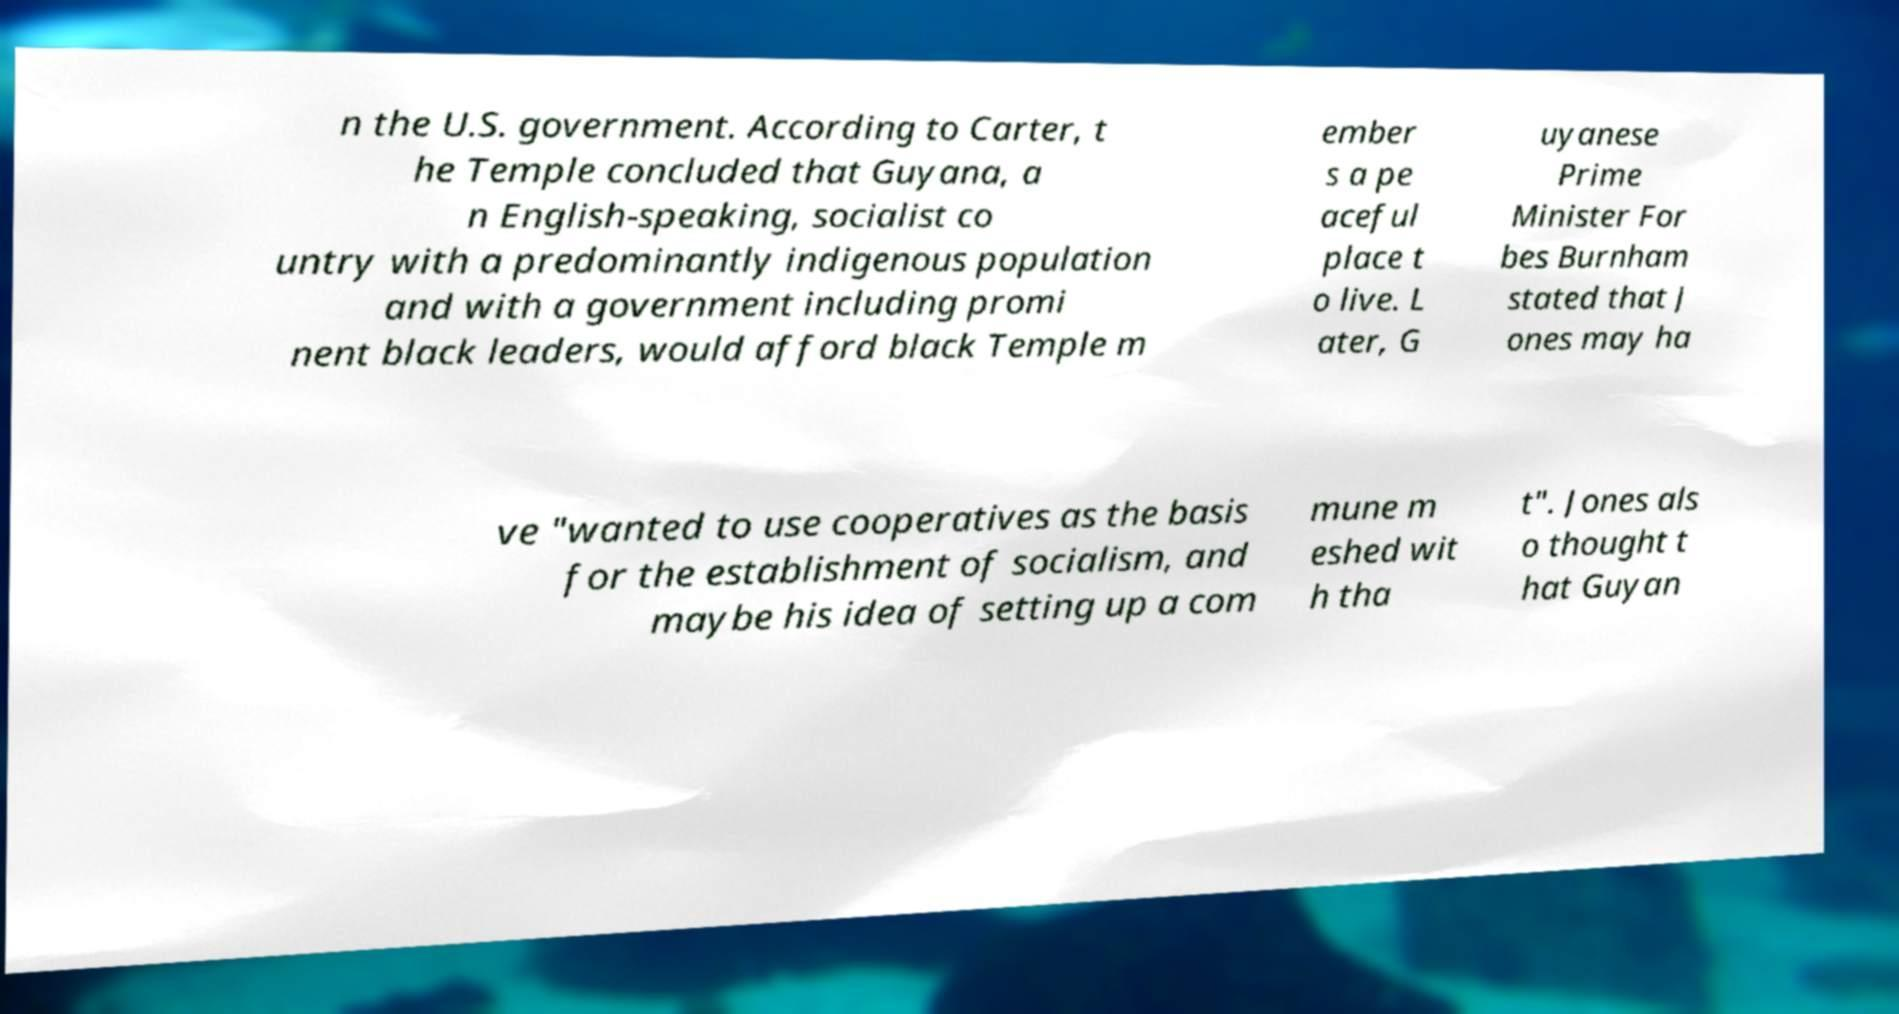Can you read and provide the text displayed in the image?This photo seems to have some interesting text. Can you extract and type it out for me? n the U.S. government. According to Carter, t he Temple concluded that Guyana, a n English-speaking, socialist co untry with a predominantly indigenous population and with a government including promi nent black leaders, would afford black Temple m ember s a pe aceful place t o live. L ater, G uyanese Prime Minister For bes Burnham stated that J ones may ha ve "wanted to use cooperatives as the basis for the establishment of socialism, and maybe his idea of setting up a com mune m eshed wit h tha t". Jones als o thought t hat Guyan 